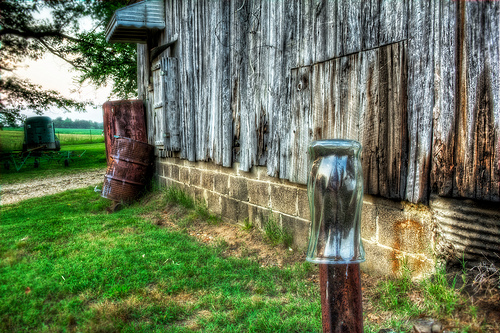<image>
Is the vase in the building? No. The vase is not contained within the building. These objects have a different spatial relationship. 